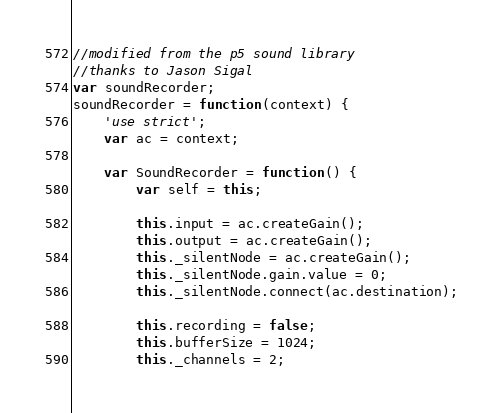Convert code to text. <code><loc_0><loc_0><loc_500><loc_500><_JavaScript_>//modified from the p5 sound library
//thanks to Jason Sigal
var soundRecorder;
soundRecorder = function(context) {
    'use strict';
    var ac = context;

    var SoundRecorder = function() {
        var self = this;

        this.input = ac.createGain();
        this.output = ac.createGain();
        this._silentNode = ac.createGain();
        this._silentNode.gain.value = 0;
        this._silentNode.connect(ac.destination);

        this.recording = false;
        this.bufferSize = 1024;
        this._channels = 2;</code> 